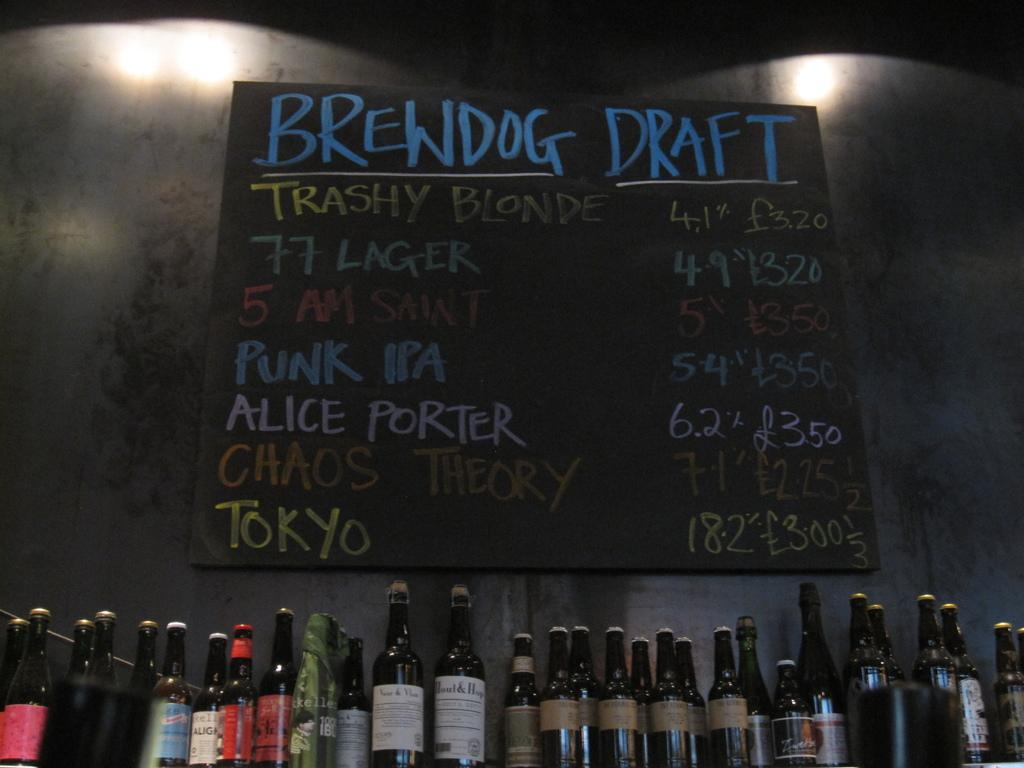<image>
Share a concise interpretation of the image provided. Brewdog Draft menu lists several beers available to order. 